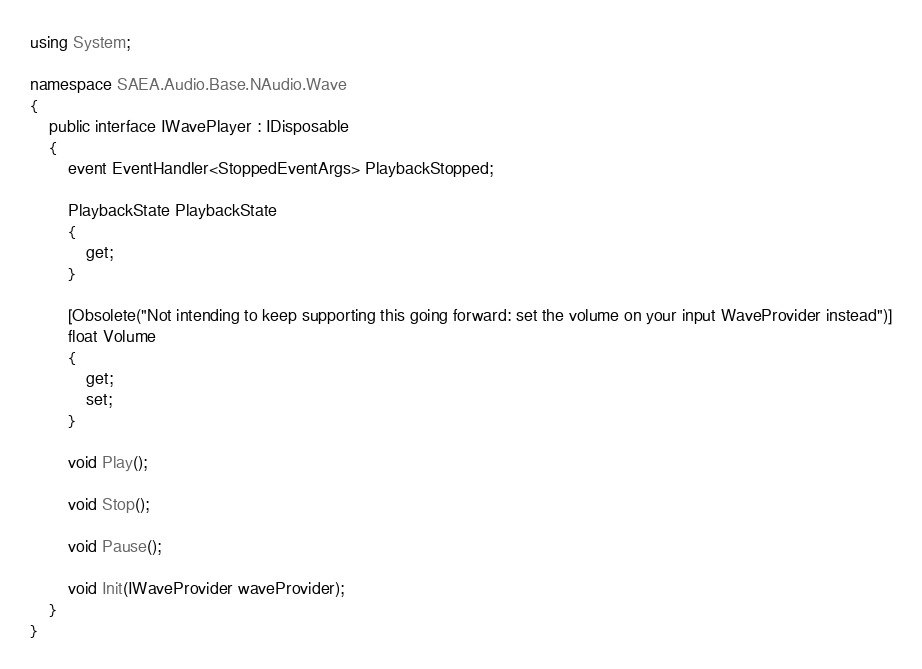<code> <loc_0><loc_0><loc_500><loc_500><_C#_>using System;

namespace SAEA.Audio.Base.NAudio.Wave
{
	public interface IWavePlayer : IDisposable
	{
		event EventHandler<StoppedEventArgs> PlaybackStopped;

		PlaybackState PlaybackState
		{
			get;
		}

		[Obsolete("Not intending to keep supporting this going forward: set the volume on your input WaveProvider instead")]
		float Volume
		{
			get;
			set;
		}

		void Play();

		void Stop();

		void Pause();

		void Init(IWaveProvider waveProvider);
	}
}
</code> 